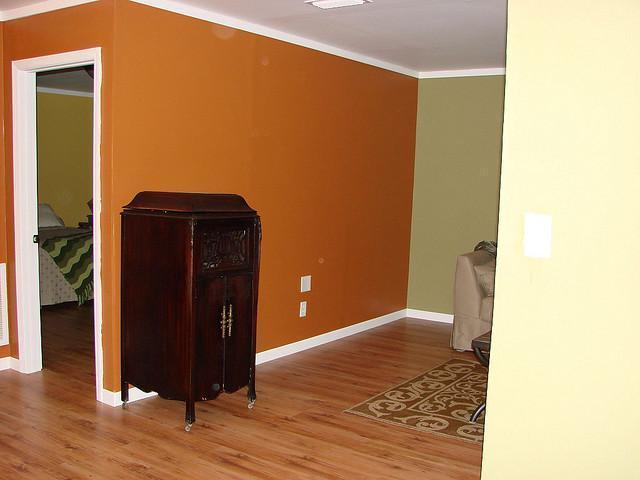How many people are sitting in the bleachers?
Give a very brief answer. 0. 